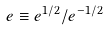Convert formula to latex. <formula><loc_0><loc_0><loc_500><loc_500>e \equiv e ^ { 1 / 2 } / e ^ { - 1 / 2 }</formula> 